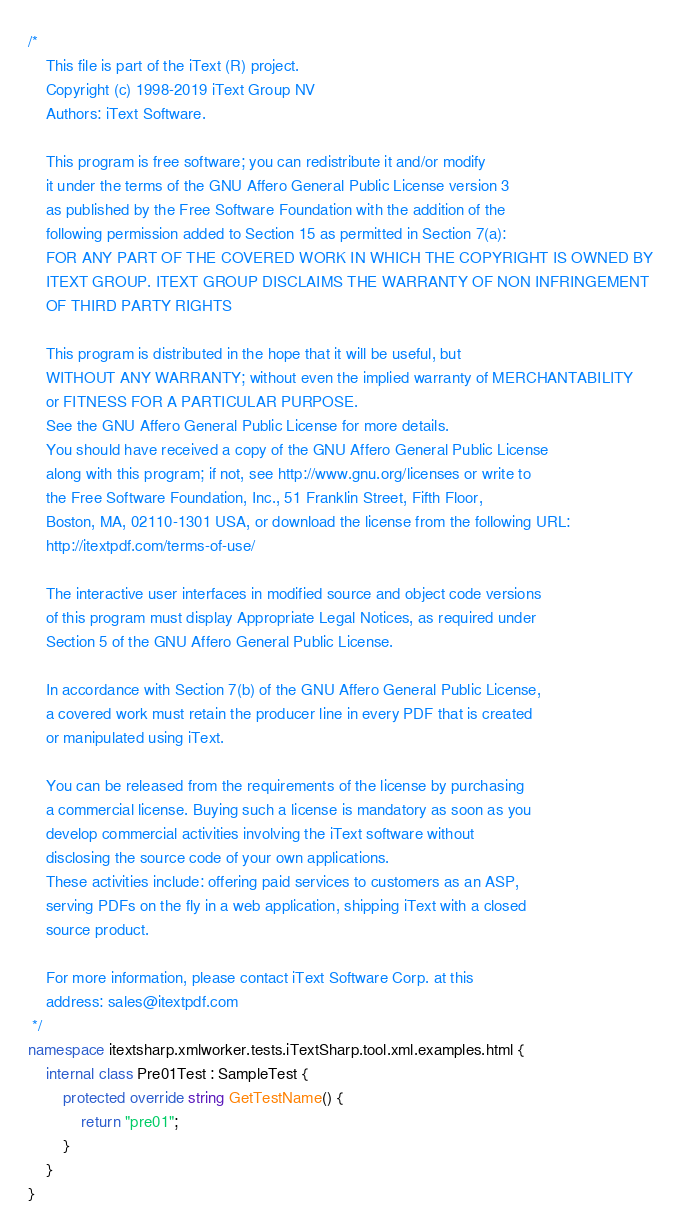Convert code to text. <code><loc_0><loc_0><loc_500><loc_500><_C#_>/*
    This file is part of the iText (R) project.
    Copyright (c) 1998-2019 iText Group NV
    Authors: iText Software.

    This program is free software; you can redistribute it and/or modify
    it under the terms of the GNU Affero General Public License version 3
    as published by the Free Software Foundation with the addition of the
    following permission added to Section 15 as permitted in Section 7(a):
    FOR ANY PART OF THE COVERED WORK IN WHICH THE COPYRIGHT IS OWNED BY
    ITEXT GROUP. ITEXT GROUP DISCLAIMS THE WARRANTY OF NON INFRINGEMENT
    OF THIRD PARTY RIGHTS
    
    This program is distributed in the hope that it will be useful, but
    WITHOUT ANY WARRANTY; without even the implied warranty of MERCHANTABILITY
    or FITNESS FOR A PARTICULAR PURPOSE.
    See the GNU Affero General Public License for more details.
    You should have received a copy of the GNU Affero General Public License
    along with this program; if not, see http://www.gnu.org/licenses or write to
    the Free Software Foundation, Inc., 51 Franklin Street, Fifth Floor,
    Boston, MA, 02110-1301 USA, or download the license from the following URL:
    http://itextpdf.com/terms-of-use/
    
    The interactive user interfaces in modified source and object code versions
    of this program must display Appropriate Legal Notices, as required under
    Section 5 of the GNU Affero General Public License.
    
    In accordance with Section 7(b) of the GNU Affero General Public License,
    a covered work must retain the producer line in every PDF that is created
    or manipulated using iText.
    
    You can be released from the requirements of the license by purchasing
    a commercial license. Buying such a license is mandatory as soon as you
    develop commercial activities involving the iText software without
    disclosing the source code of your own applications.
    These activities include: offering paid services to customers as an ASP,
    serving PDFs on the fly in a web application, shipping iText with a closed
    source product.
    
    For more information, please contact iText Software Corp. at this
    address: sales@itextpdf.com
 */
namespace itextsharp.xmlworker.tests.iTextSharp.tool.xml.examples.html {
    internal class Pre01Test : SampleTest {
        protected override string GetTestName() {
            return "pre01";
        }
    }
}
</code> 